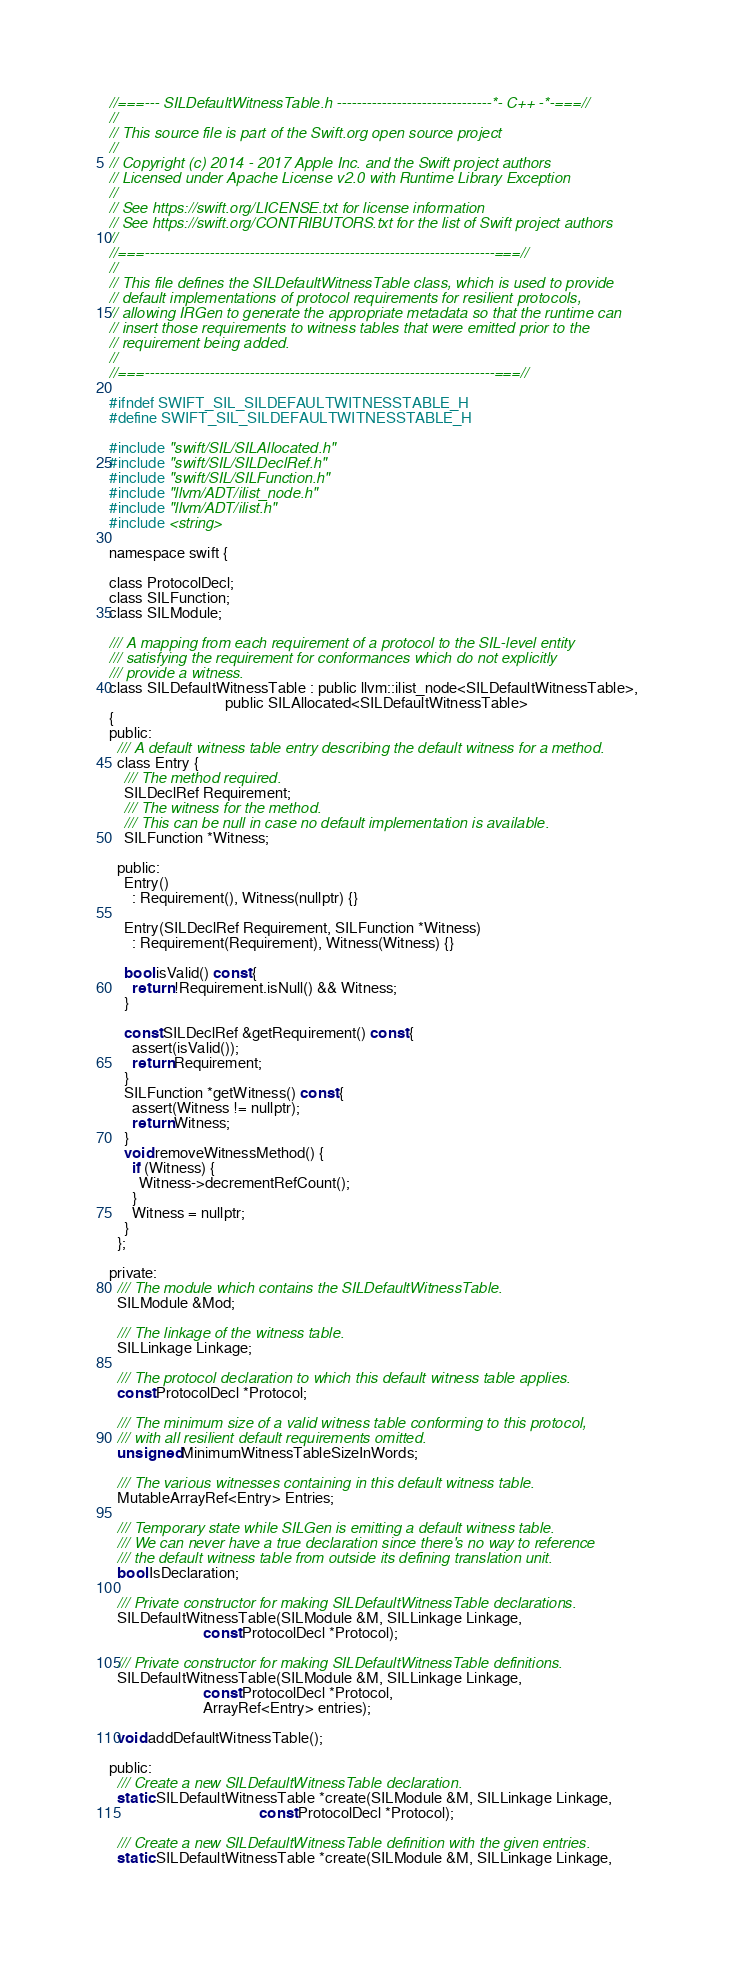Convert code to text. <code><loc_0><loc_0><loc_500><loc_500><_C_>//===--- SILDefaultWitnessTable.h -------------------------------*- C++ -*-===//
//
// This source file is part of the Swift.org open source project
//
// Copyright (c) 2014 - 2017 Apple Inc. and the Swift project authors
// Licensed under Apache License v2.0 with Runtime Library Exception
//
// See https://swift.org/LICENSE.txt for license information
// See https://swift.org/CONTRIBUTORS.txt for the list of Swift project authors
//
//===----------------------------------------------------------------------===//
//
// This file defines the SILDefaultWitnessTable class, which is used to provide
// default implementations of protocol requirements for resilient protocols,
// allowing IRGen to generate the appropriate metadata so that the runtime can
// insert those requirements to witness tables that were emitted prior to the
// requirement being added.
//
//===----------------------------------------------------------------------===//

#ifndef SWIFT_SIL_SILDEFAULTWITNESSTABLE_H
#define SWIFT_SIL_SILDEFAULTWITNESSTABLE_H

#include "swift/SIL/SILAllocated.h"
#include "swift/SIL/SILDeclRef.h"
#include "swift/SIL/SILFunction.h"
#include "llvm/ADT/ilist_node.h"
#include "llvm/ADT/ilist.h"
#include <string>

namespace swift {

class ProtocolDecl;
class SILFunction;
class SILModule;

/// A mapping from each requirement of a protocol to the SIL-level entity
/// satisfying the requirement for conformances which do not explicitly
/// provide a witness.
class SILDefaultWitnessTable : public llvm::ilist_node<SILDefaultWitnessTable>,
                               public SILAllocated<SILDefaultWitnessTable>
{
public:
  /// A default witness table entry describing the default witness for a method.
  class Entry {
    /// The method required.
    SILDeclRef Requirement;
    /// The witness for the method.
    /// This can be null in case no default implementation is available.
    SILFunction *Witness;
 
  public:
    Entry()
      : Requirement(), Witness(nullptr) {}
    
    Entry(SILDeclRef Requirement, SILFunction *Witness)
      : Requirement(Requirement), Witness(Witness) {}

    bool isValid() const {
      return !Requirement.isNull() && Witness;
    }

    const SILDeclRef &getRequirement() const {
      assert(isValid());
      return Requirement;
    }
    SILFunction *getWitness() const {
      assert(Witness != nullptr);
      return Witness;
    }
    void removeWitnessMethod() {
      if (Witness) {
        Witness->decrementRefCount();
      }
      Witness = nullptr;
    }
  };
 
private:
  /// The module which contains the SILDefaultWitnessTable.
  SILModule &Mod;

  /// The linkage of the witness table.
  SILLinkage Linkage;

  /// The protocol declaration to which this default witness table applies.
  const ProtocolDecl *Protocol;

  /// The minimum size of a valid witness table conforming to this protocol,
  /// with all resilient default requirements omitted.
  unsigned MinimumWitnessTableSizeInWords;

  /// The various witnesses containing in this default witness table.
  MutableArrayRef<Entry> Entries;

  /// Temporary state while SILGen is emitting a default witness table.
  /// We can never have a true declaration since there's no way to reference
  /// the default witness table from outside its defining translation unit.
  bool IsDeclaration;

  /// Private constructor for making SILDefaultWitnessTable declarations.
  SILDefaultWitnessTable(SILModule &M, SILLinkage Linkage,
                         const ProtocolDecl *Protocol);

  /// Private constructor for making SILDefaultWitnessTable definitions.
  SILDefaultWitnessTable(SILModule &M, SILLinkage Linkage,
                         const ProtocolDecl *Protocol,
                         ArrayRef<Entry> entries);

  void addDefaultWitnessTable();

public:
  /// Create a new SILDefaultWitnessTable declaration.
  static SILDefaultWitnessTable *create(SILModule &M, SILLinkage Linkage,
                                        const ProtocolDecl *Protocol);

  /// Create a new SILDefaultWitnessTable definition with the given entries.
  static SILDefaultWitnessTable *create(SILModule &M, SILLinkage Linkage,</code> 